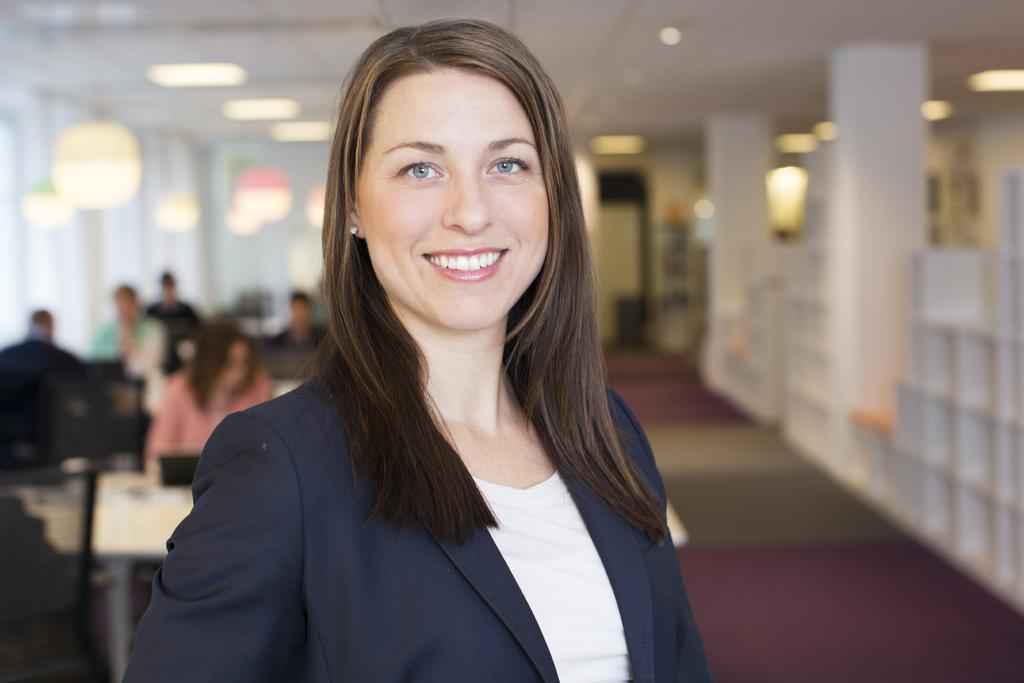What is the woman in the image doing? The woman is standing in the image and smiling. What can be seen in the background of the image? There is a group of persons sitting in the background of the image. What is visible in the image besides the woman and the group of persons? There are lights visible in the image. How would you describe the quality of the image? The image is blurry in some areas. What type of cloud can be seen in the image? There is no cloud present in the image. Is the woman sitting in the yard in the image? There is no yard or indication of an outdoor setting in the image. 